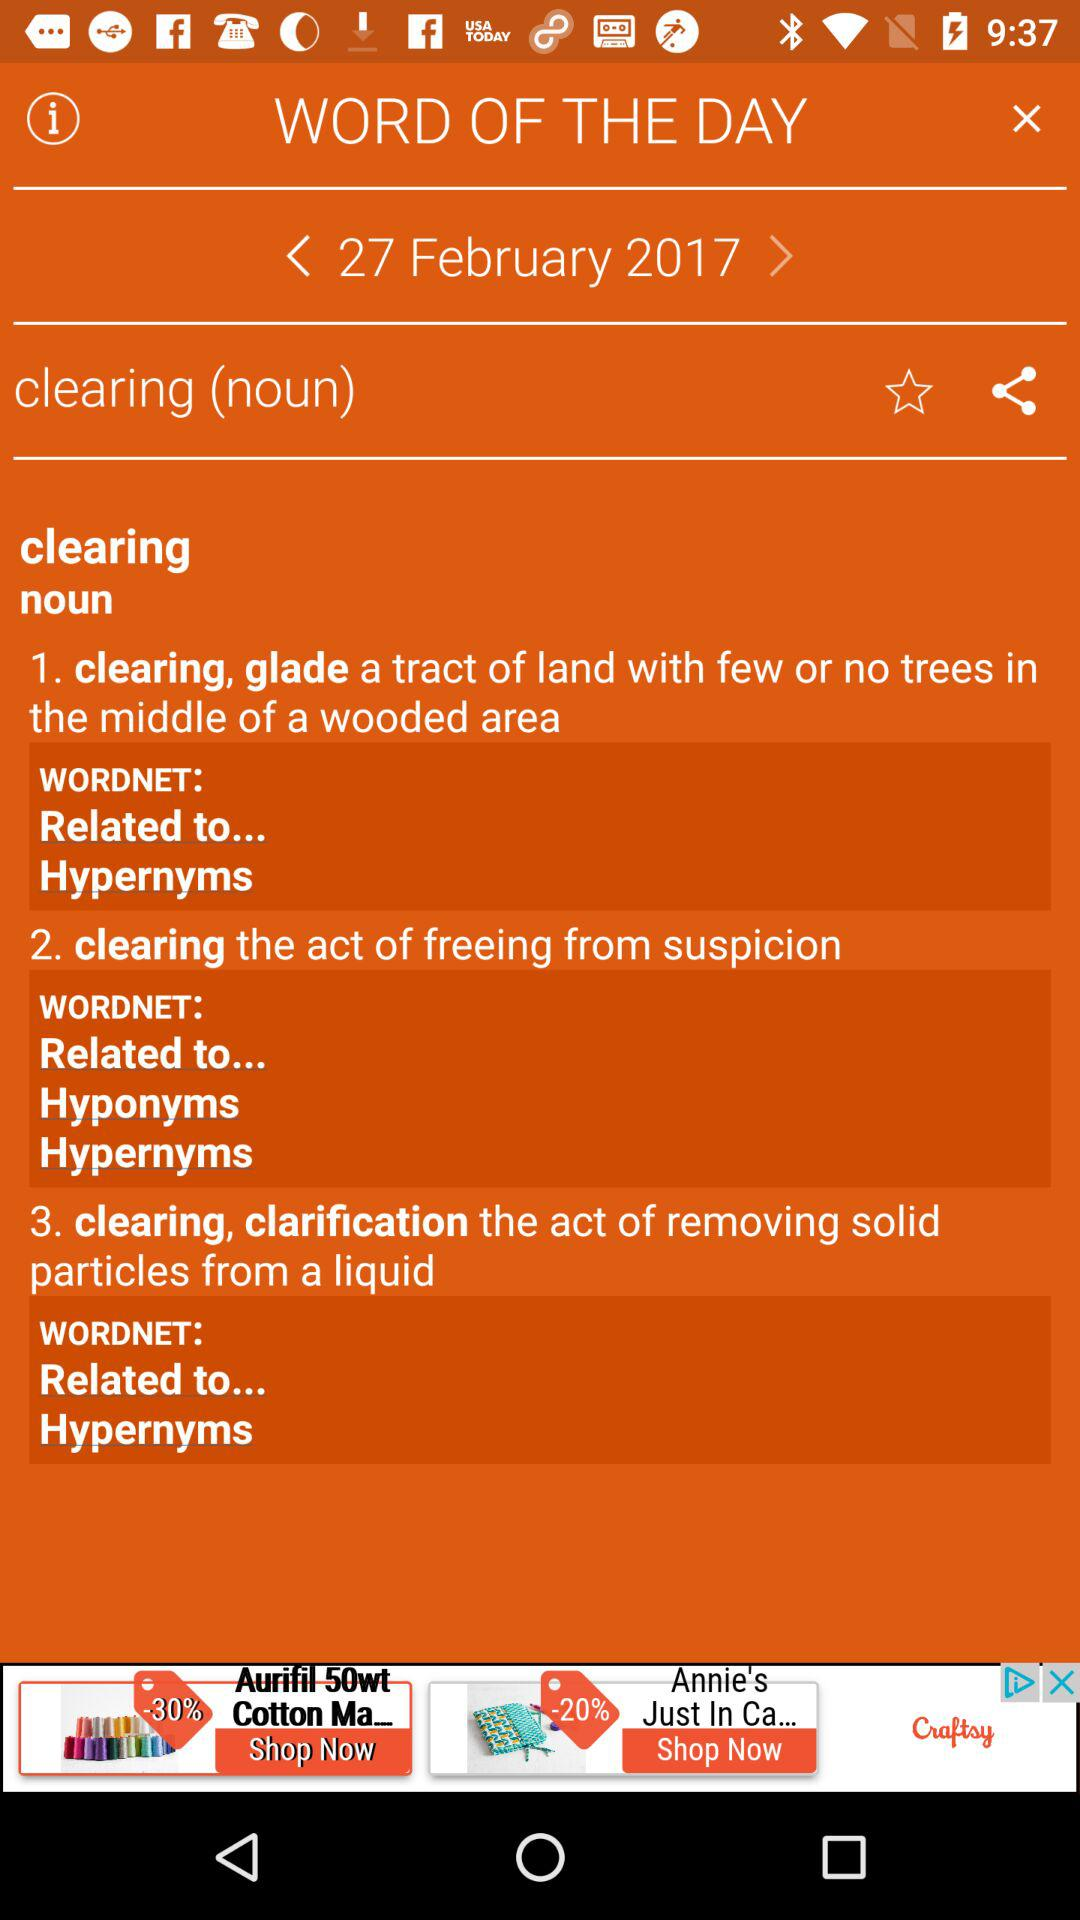Through which applications can this be shared?
When the provided information is insufficient, respond with <no answer>. <no answer> 